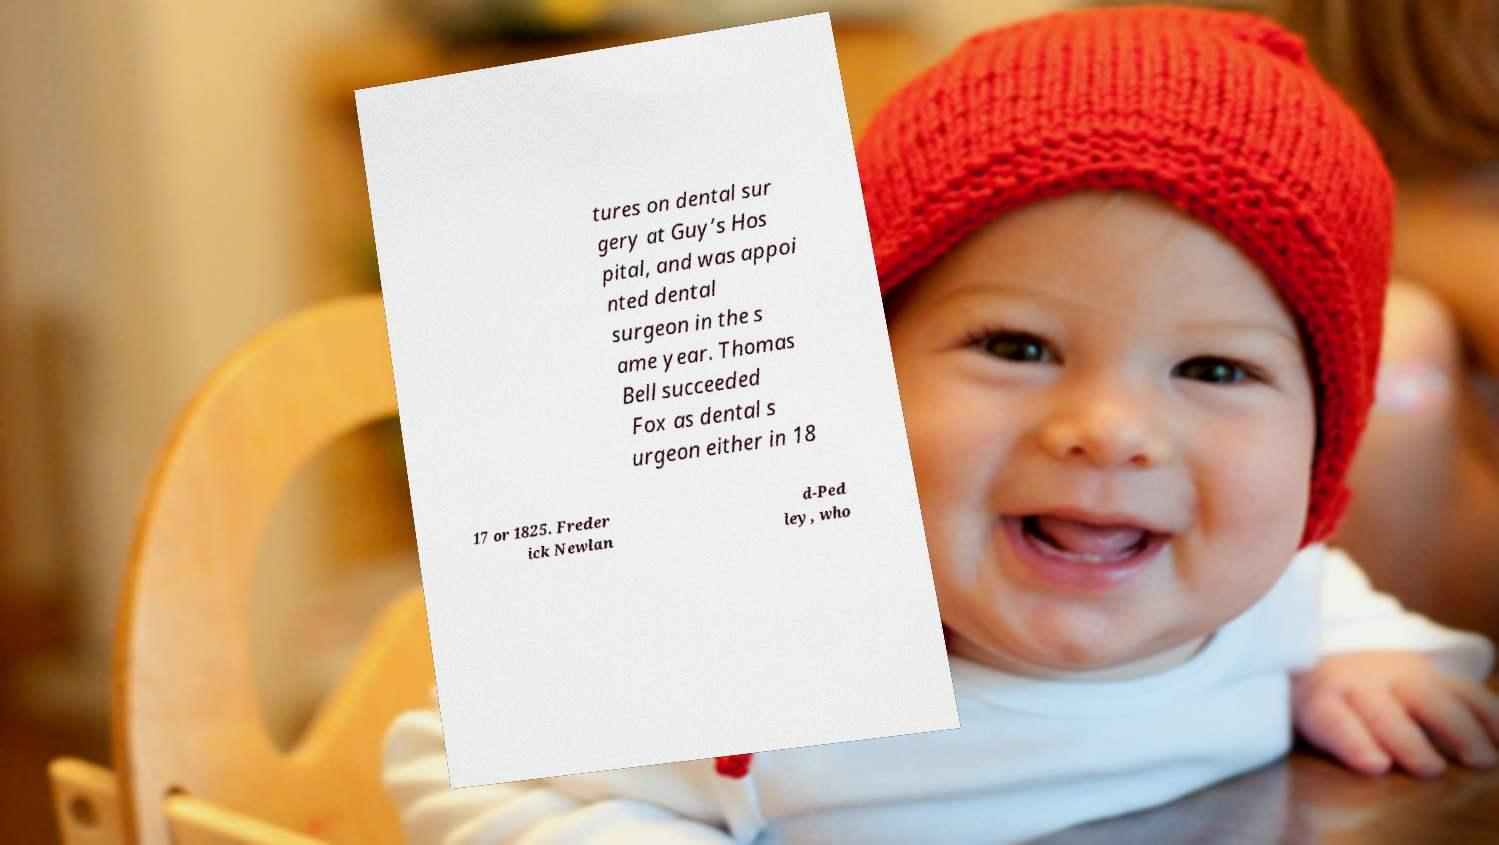Please read and relay the text visible in this image. What does it say? tures on dental sur gery at Guy’s Hos pital, and was appoi nted dental surgeon in the s ame year. Thomas Bell succeeded Fox as dental s urgeon either in 18 17 or 1825. Freder ick Newlan d-Ped ley, who 